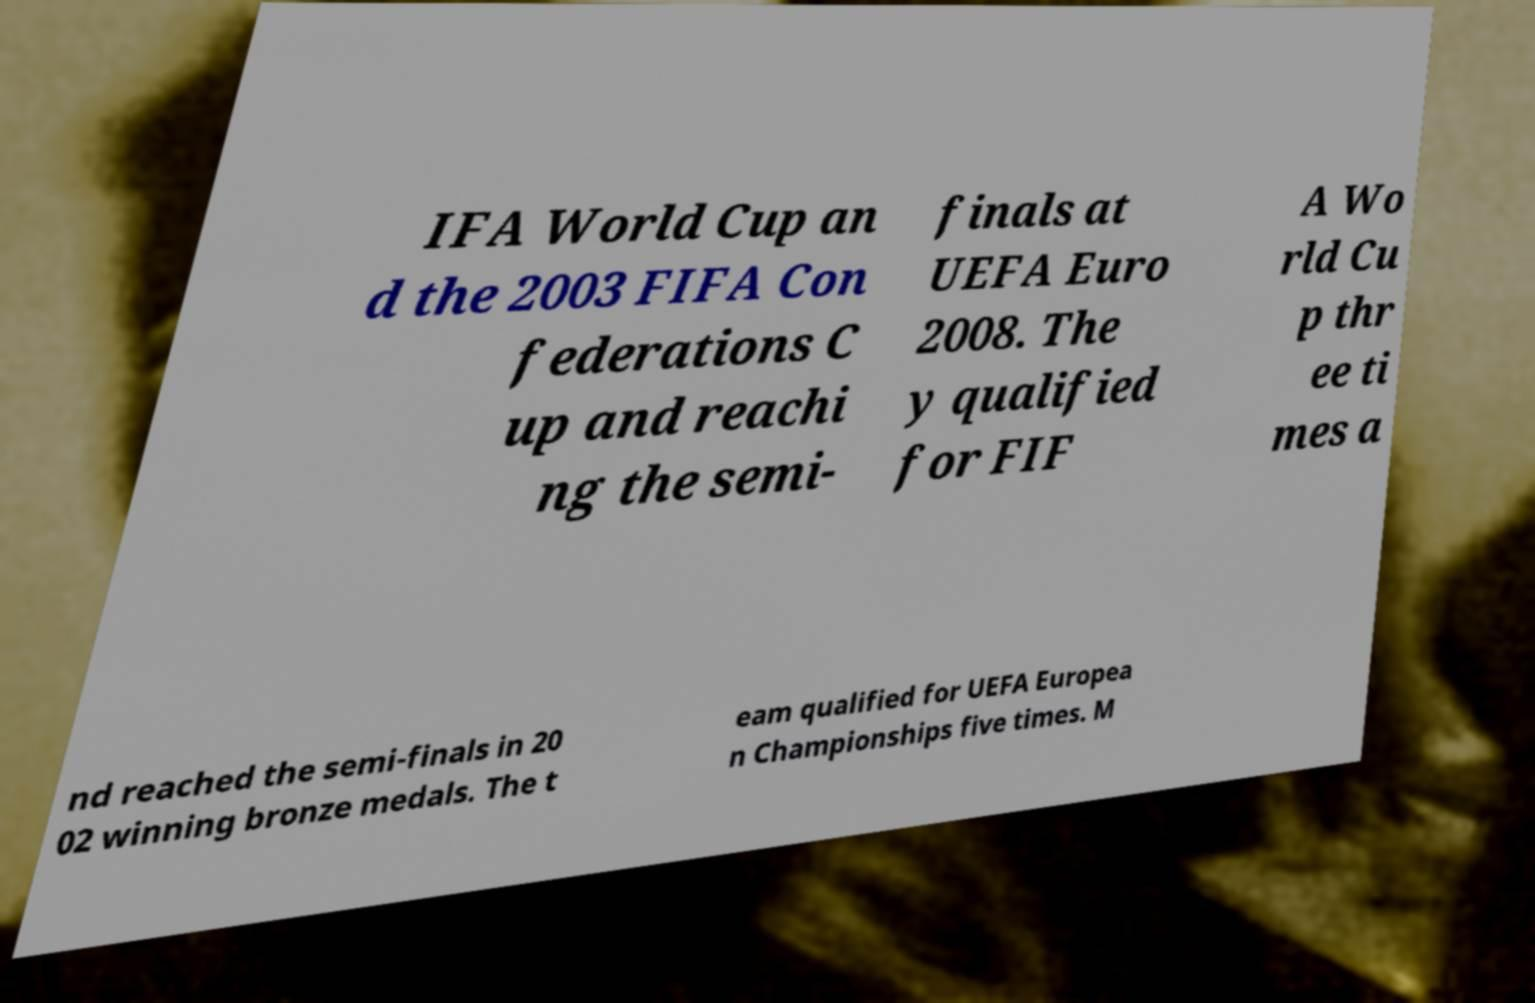Could you extract and type out the text from this image? IFA World Cup an d the 2003 FIFA Con federations C up and reachi ng the semi- finals at UEFA Euro 2008. The y qualified for FIF A Wo rld Cu p thr ee ti mes a nd reached the semi-finals in 20 02 winning bronze medals. The t eam qualified for UEFA Europea n Championships five times. M 